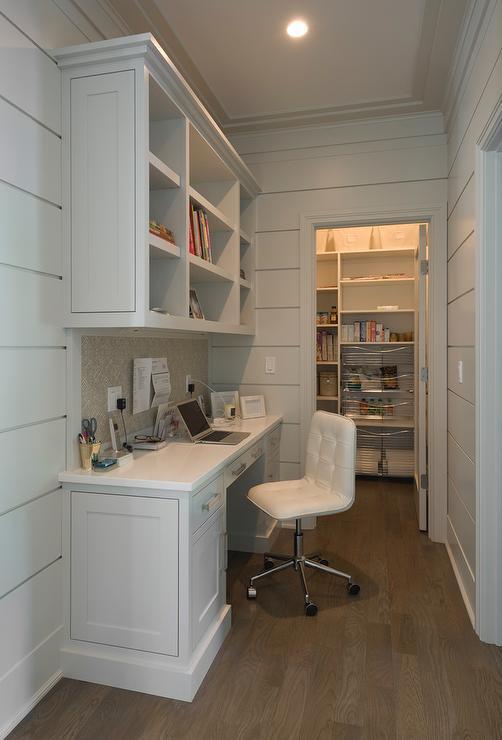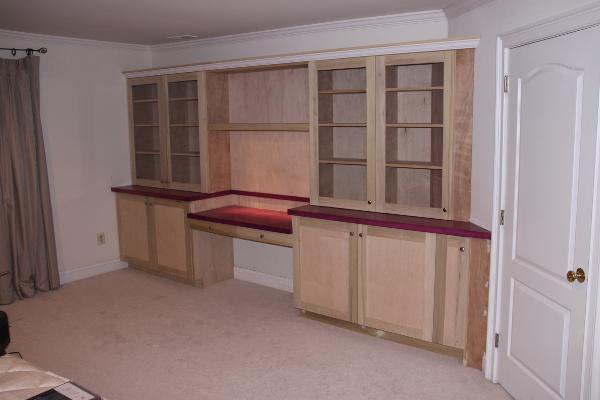The first image is the image on the left, the second image is the image on the right. For the images shown, is this caption "In one image, a center desk space has two open upper shelving units on each side with corresponding closed units below." true? Answer yes or no. Yes. The first image is the image on the left, the second image is the image on the right. Given the left and right images, does the statement "An image shows a chair pulled up to a white desk, which sits under a wall-mounted white shelf unit." hold true? Answer yes or no. Yes. 